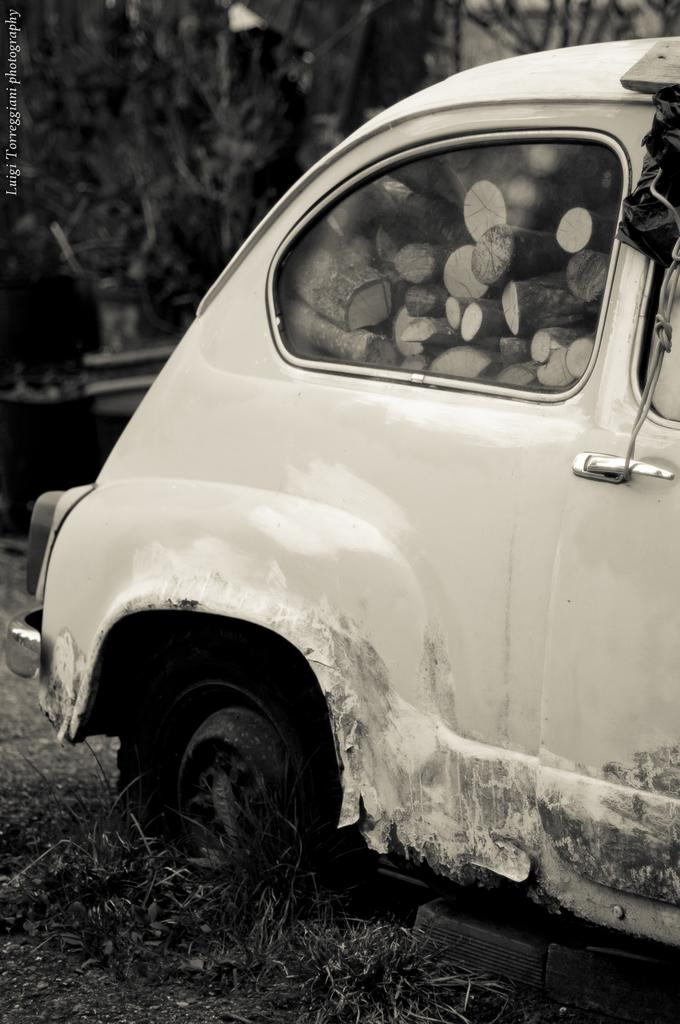What is the main subject of the image? There is a vehicle in the image. What can be seen in the background of the image? There are trees behind the vehicle in the image. What type of vegetation is present in the image? There are plants in the image. What is at the bottom of the image? There is grass at the bottom of the image. How many tin houses are visible in the image? There are no tin houses present in the image. Is the vehicle in the image driving or parked? The provided facts do not indicate whether the vehicle is driving or parked. 